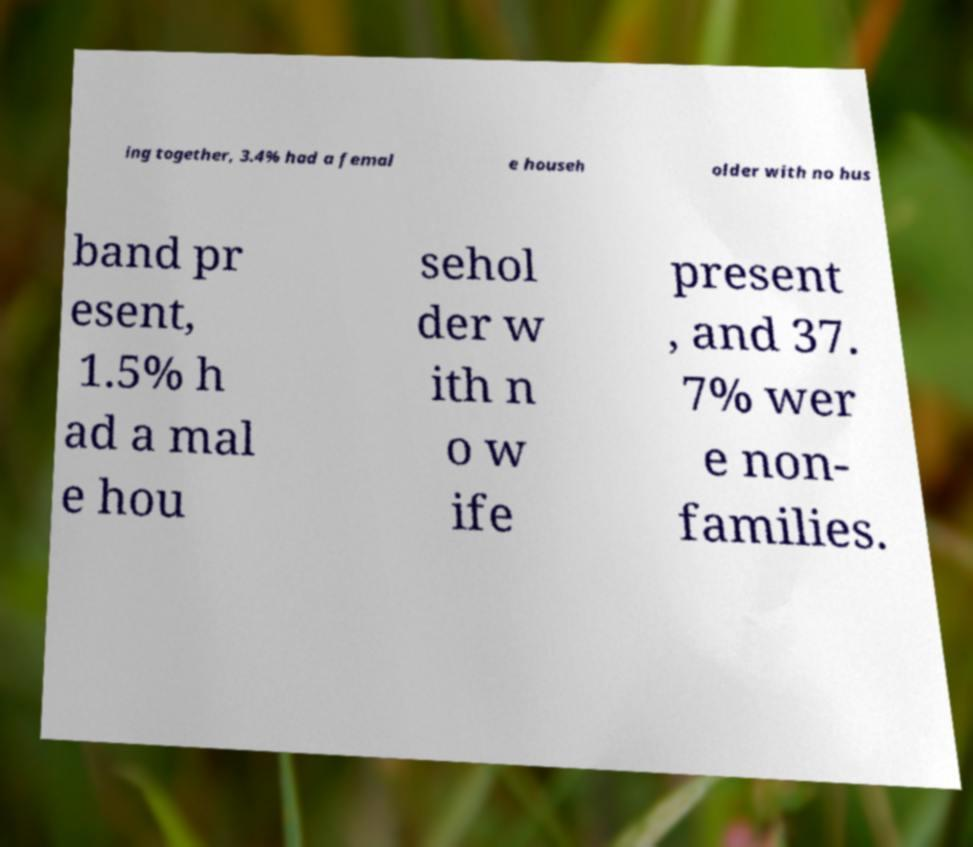Please read and relay the text visible in this image. What does it say? ing together, 3.4% had a femal e househ older with no hus band pr esent, 1.5% h ad a mal e hou sehol der w ith n o w ife present , and 37. 7% wer e non- families. 